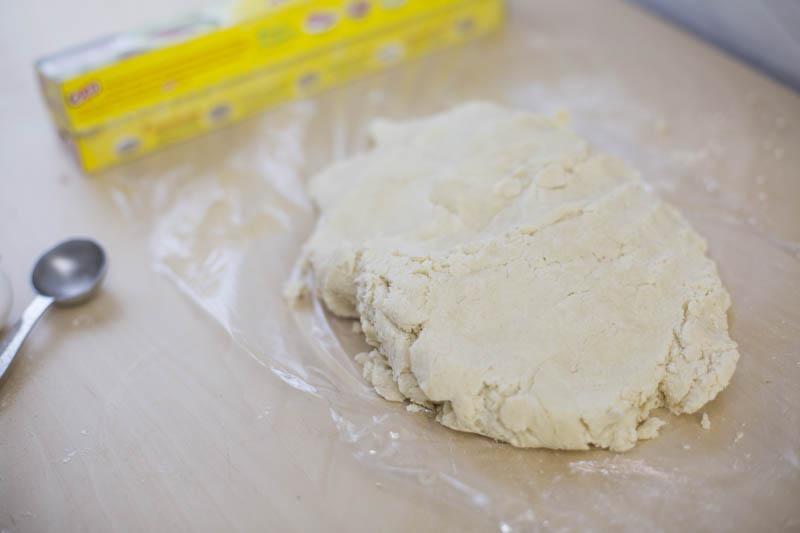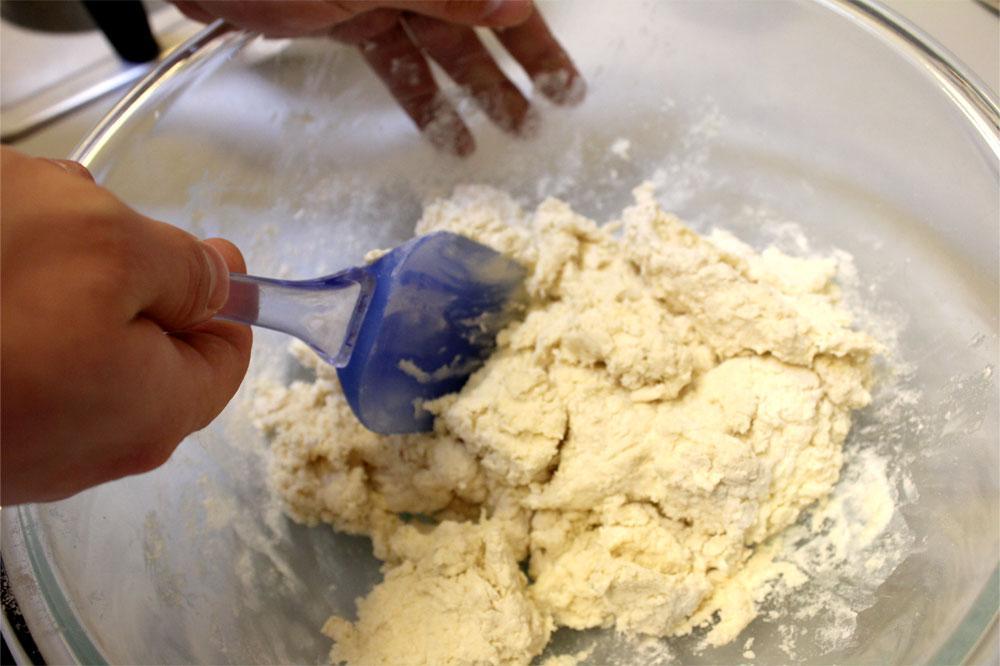The first image is the image on the left, the second image is the image on the right. Assess this claim about the two images: "Each image shows a utensil in a bowl of food mixture, and one image shows one hand stirring with the utensil as the other hand holds the edge of the bowl.". Correct or not? Answer yes or no. No. The first image is the image on the left, the second image is the image on the right. Analyze the images presented: Is the assertion "In exactly one of the images a person is mixing dough with a utensil." valid? Answer yes or no. Yes. 